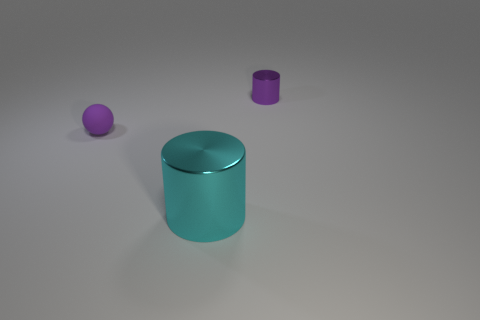Subtract 1 cylinders. How many cylinders are left? 1 Subtract all cylinders. How many objects are left? 1 Subtract all cyan cylinders. How many cylinders are left? 1 Add 2 small balls. How many small balls exist? 3 Add 3 large green metal spheres. How many objects exist? 6 Subtract 1 cyan cylinders. How many objects are left? 2 Subtract all red balls. Subtract all gray blocks. How many balls are left? 1 Subtract all blue balls. How many purple cylinders are left? 1 Subtract all tiny matte spheres. Subtract all yellow things. How many objects are left? 2 Add 3 large objects. How many large objects are left? 4 